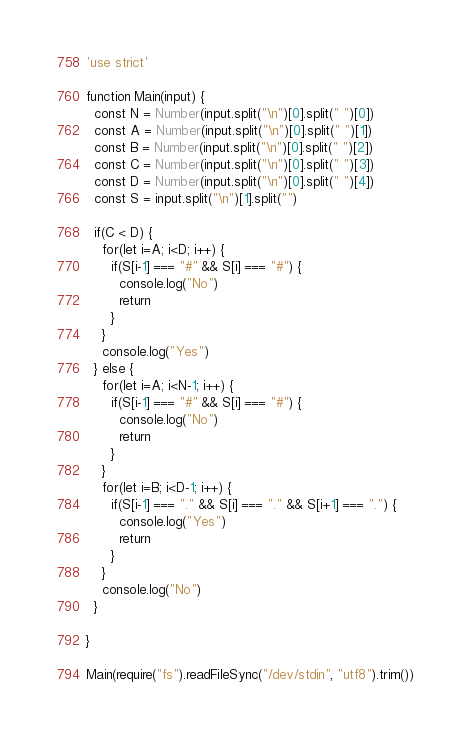Convert code to text. <code><loc_0><loc_0><loc_500><loc_500><_JavaScript_>'use strict'

function Main(input) {
  const N = Number(input.split("\n")[0].split(" ")[0])
  const A = Number(input.split("\n")[0].split(" ")[1])
  const B = Number(input.split("\n")[0].split(" ")[2])
  const C = Number(input.split("\n")[0].split(" ")[3])
  const D = Number(input.split("\n")[0].split(" ")[4])
  const S = input.split("\n")[1].split("")

  if(C < D) {
    for(let i=A; i<D; i++) {
      if(S[i-1] === "#" && S[i] === "#") {
        console.log("No")
        return
      }
    }
    console.log("Yes")
  } else {
    for(let i=A; i<N-1; i++) {
      if(S[i-1] === "#" && S[i] === "#") {
        console.log("No")
        return
      }
    }
    for(let i=B; i<D-1; i++) {
      if(S[i-1] === "." && S[i] === "." && S[i+1] === ".") {
        console.log("Yes")
        return
      }
    }
    console.log("No")
  }

}

Main(require("fs").readFileSync("/dev/stdin", "utf8").trim())
</code> 